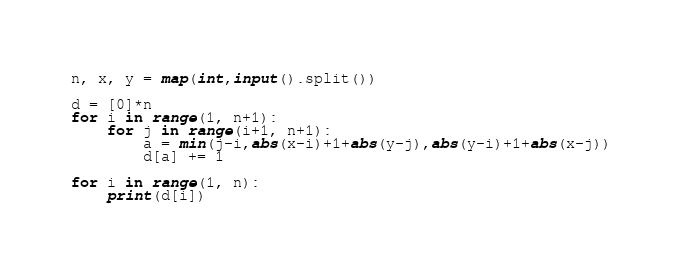Convert code to text. <code><loc_0><loc_0><loc_500><loc_500><_Python_>n, x, y = map(int,input().split())

d = [0]*n
for i in range(1, n+1):
    for j in range(i+1, n+1):
        a = min(j-i,abs(x-i)+1+abs(y-j),abs(y-i)+1+abs(x-j))
        d[a] += 1

for i in range(1, n):
    print(d[i])</code> 